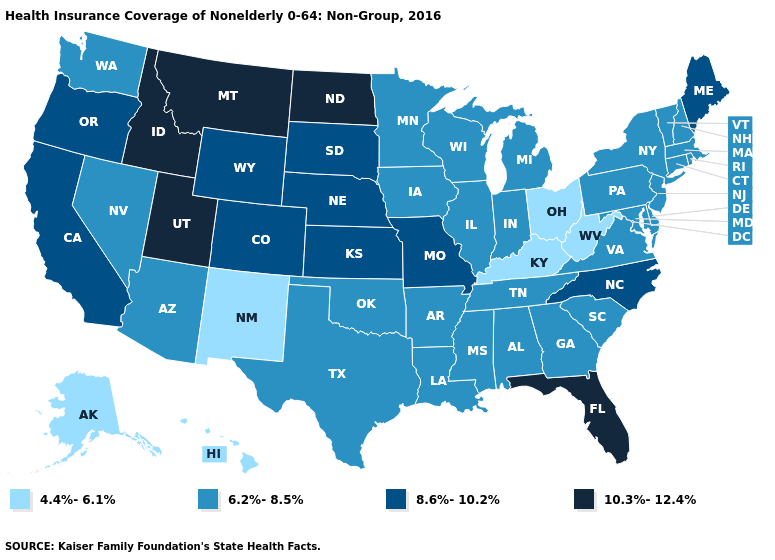Which states have the lowest value in the South?
Answer briefly. Kentucky, West Virginia. What is the value of Nebraska?
Quick response, please. 8.6%-10.2%. What is the lowest value in the USA?
Quick response, please. 4.4%-6.1%. Is the legend a continuous bar?
Write a very short answer. No. Name the states that have a value in the range 6.2%-8.5%?
Short answer required. Alabama, Arizona, Arkansas, Connecticut, Delaware, Georgia, Illinois, Indiana, Iowa, Louisiana, Maryland, Massachusetts, Michigan, Minnesota, Mississippi, Nevada, New Hampshire, New Jersey, New York, Oklahoma, Pennsylvania, Rhode Island, South Carolina, Tennessee, Texas, Vermont, Virginia, Washington, Wisconsin. Does Minnesota have a higher value than Alabama?
Keep it brief. No. What is the value of West Virginia?
Write a very short answer. 4.4%-6.1%. Name the states that have a value in the range 4.4%-6.1%?
Be succinct. Alaska, Hawaii, Kentucky, New Mexico, Ohio, West Virginia. What is the value of West Virginia?
Write a very short answer. 4.4%-6.1%. How many symbols are there in the legend?
Write a very short answer. 4. Is the legend a continuous bar?
Keep it brief. No. Among the states that border Oklahoma , which have the lowest value?
Keep it brief. New Mexico. Name the states that have a value in the range 4.4%-6.1%?
Keep it brief. Alaska, Hawaii, Kentucky, New Mexico, Ohio, West Virginia. Name the states that have a value in the range 4.4%-6.1%?
Write a very short answer. Alaska, Hawaii, Kentucky, New Mexico, Ohio, West Virginia. 